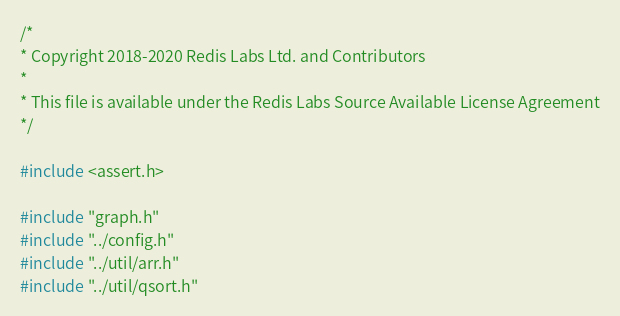<code> <loc_0><loc_0><loc_500><loc_500><_C_>/*
* Copyright 2018-2020 Redis Labs Ltd. and Contributors
*
* This file is available under the Redis Labs Source Available License Agreement
*/

#include <assert.h>

#include "graph.h"
#include "../config.h"
#include "../util/arr.h"
#include "../util/qsort.h"</code> 